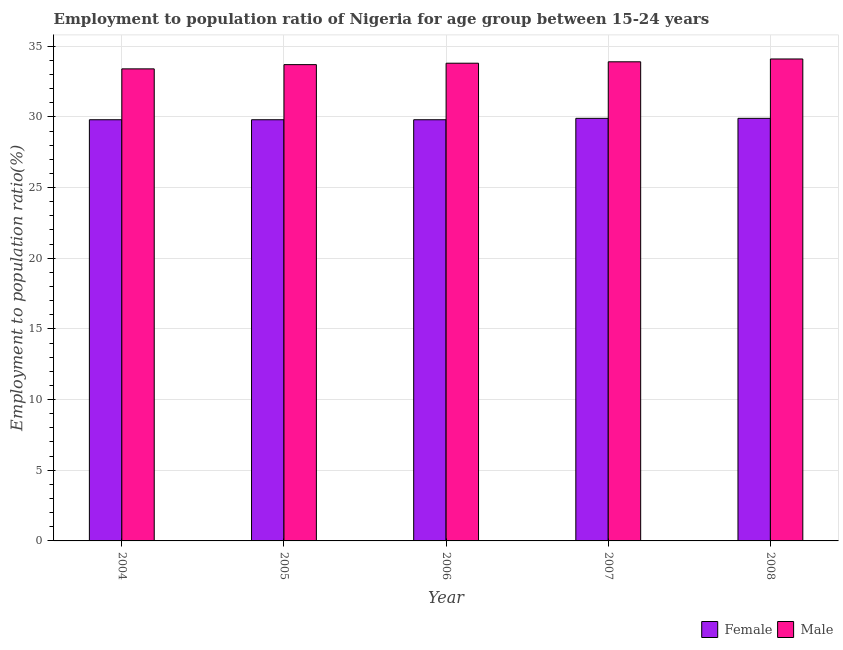How many groups of bars are there?
Make the answer very short. 5. How many bars are there on the 2nd tick from the left?
Give a very brief answer. 2. In how many cases, is the number of bars for a given year not equal to the number of legend labels?
Your answer should be very brief. 0. What is the employment to population ratio(male) in 2008?
Provide a succinct answer. 34.1. Across all years, what is the maximum employment to population ratio(male)?
Your answer should be very brief. 34.1. Across all years, what is the minimum employment to population ratio(female)?
Give a very brief answer. 29.8. In which year was the employment to population ratio(female) maximum?
Give a very brief answer. 2007. In which year was the employment to population ratio(male) minimum?
Your answer should be very brief. 2004. What is the total employment to population ratio(female) in the graph?
Your answer should be compact. 149.2. What is the difference between the employment to population ratio(female) in 2006 and that in 2008?
Provide a short and direct response. -0.1. What is the difference between the employment to population ratio(male) in 2005 and the employment to population ratio(female) in 2007?
Your answer should be compact. -0.2. What is the average employment to population ratio(male) per year?
Keep it short and to the point. 33.78. In how many years, is the employment to population ratio(male) greater than 29 %?
Ensure brevity in your answer.  5. What is the ratio of the employment to population ratio(female) in 2005 to that in 2008?
Your answer should be very brief. 1. Is the difference between the employment to population ratio(male) in 2004 and 2007 greater than the difference between the employment to population ratio(female) in 2004 and 2007?
Your response must be concise. No. What is the difference between the highest and the second highest employment to population ratio(female)?
Your answer should be very brief. 0. What is the difference between the highest and the lowest employment to population ratio(male)?
Ensure brevity in your answer.  0.7. In how many years, is the employment to population ratio(male) greater than the average employment to population ratio(male) taken over all years?
Offer a terse response. 3. What does the 1st bar from the right in 2008 represents?
Provide a short and direct response. Male. Are all the bars in the graph horizontal?
Offer a very short reply. No. How many years are there in the graph?
Your response must be concise. 5. How many legend labels are there?
Your answer should be compact. 2. How are the legend labels stacked?
Offer a very short reply. Horizontal. What is the title of the graph?
Provide a succinct answer. Employment to population ratio of Nigeria for age group between 15-24 years. What is the label or title of the X-axis?
Provide a short and direct response. Year. What is the label or title of the Y-axis?
Provide a succinct answer. Employment to population ratio(%). What is the Employment to population ratio(%) of Female in 2004?
Your answer should be very brief. 29.8. What is the Employment to population ratio(%) of Male in 2004?
Ensure brevity in your answer.  33.4. What is the Employment to population ratio(%) in Female in 2005?
Offer a very short reply. 29.8. What is the Employment to population ratio(%) of Male in 2005?
Your response must be concise. 33.7. What is the Employment to population ratio(%) of Female in 2006?
Your answer should be very brief. 29.8. What is the Employment to population ratio(%) of Male in 2006?
Your response must be concise. 33.8. What is the Employment to population ratio(%) of Female in 2007?
Your answer should be very brief. 29.9. What is the Employment to population ratio(%) in Male in 2007?
Offer a very short reply. 33.9. What is the Employment to population ratio(%) in Female in 2008?
Keep it short and to the point. 29.9. What is the Employment to population ratio(%) of Male in 2008?
Provide a succinct answer. 34.1. Across all years, what is the maximum Employment to population ratio(%) in Female?
Your answer should be compact. 29.9. Across all years, what is the maximum Employment to population ratio(%) in Male?
Keep it short and to the point. 34.1. Across all years, what is the minimum Employment to population ratio(%) of Female?
Your answer should be very brief. 29.8. Across all years, what is the minimum Employment to population ratio(%) in Male?
Your answer should be very brief. 33.4. What is the total Employment to population ratio(%) in Female in the graph?
Provide a succinct answer. 149.2. What is the total Employment to population ratio(%) in Male in the graph?
Keep it short and to the point. 168.9. What is the difference between the Employment to population ratio(%) of Male in 2004 and that in 2005?
Your answer should be compact. -0.3. What is the difference between the Employment to population ratio(%) in Female in 2004 and that in 2006?
Offer a terse response. 0. What is the difference between the Employment to population ratio(%) in Female in 2004 and that in 2007?
Make the answer very short. -0.1. What is the difference between the Employment to population ratio(%) in Male in 2004 and that in 2008?
Make the answer very short. -0.7. What is the difference between the Employment to population ratio(%) in Male in 2005 and that in 2006?
Give a very brief answer. -0.1. What is the difference between the Employment to population ratio(%) in Male in 2005 and that in 2008?
Your answer should be very brief. -0.4. What is the difference between the Employment to population ratio(%) of Female in 2006 and that in 2007?
Provide a short and direct response. -0.1. What is the difference between the Employment to population ratio(%) in Female in 2006 and that in 2008?
Your response must be concise. -0.1. What is the difference between the Employment to population ratio(%) of Female in 2007 and that in 2008?
Your response must be concise. 0. What is the difference between the Employment to population ratio(%) of Male in 2007 and that in 2008?
Your answer should be compact. -0.2. What is the difference between the Employment to population ratio(%) in Female in 2004 and the Employment to population ratio(%) in Male in 2008?
Give a very brief answer. -4.3. What is the difference between the Employment to population ratio(%) in Female in 2005 and the Employment to population ratio(%) in Male in 2008?
Your answer should be compact. -4.3. What is the difference between the Employment to population ratio(%) of Female in 2006 and the Employment to population ratio(%) of Male in 2007?
Provide a succinct answer. -4.1. What is the difference between the Employment to population ratio(%) of Female in 2006 and the Employment to population ratio(%) of Male in 2008?
Your answer should be compact. -4.3. What is the difference between the Employment to population ratio(%) in Female in 2007 and the Employment to population ratio(%) in Male in 2008?
Your answer should be very brief. -4.2. What is the average Employment to population ratio(%) of Female per year?
Your answer should be very brief. 29.84. What is the average Employment to population ratio(%) of Male per year?
Make the answer very short. 33.78. In the year 2005, what is the difference between the Employment to population ratio(%) in Female and Employment to population ratio(%) in Male?
Keep it short and to the point. -3.9. In the year 2008, what is the difference between the Employment to population ratio(%) of Female and Employment to population ratio(%) of Male?
Give a very brief answer. -4.2. What is the ratio of the Employment to population ratio(%) in Female in 2004 to that in 2005?
Your answer should be very brief. 1. What is the ratio of the Employment to population ratio(%) in Male in 2004 to that in 2005?
Offer a terse response. 0.99. What is the ratio of the Employment to population ratio(%) of Female in 2004 to that in 2006?
Make the answer very short. 1. What is the ratio of the Employment to population ratio(%) in Male in 2004 to that in 2007?
Provide a succinct answer. 0.99. What is the ratio of the Employment to population ratio(%) in Male in 2004 to that in 2008?
Provide a succinct answer. 0.98. What is the ratio of the Employment to population ratio(%) in Female in 2005 to that in 2006?
Keep it short and to the point. 1. What is the ratio of the Employment to population ratio(%) in Male in 2005 to that in 2006?
Make the answer very short. 1. What is the ratio of the Employment to population ratio(%) in Female in 2005 to that in 2007?
Your answer should be compact. 1. What is the ratio of the Employment to population ratio(%) in Male in 2005 to that in 2007?
Your response must be concise. 0.99. What is the ratio of the Employment to population ratio(%) of Male in 2005 to that in 2008?
Offer a terse response. 0.99. What is the ratio of the Employment to population ratio(%) of Female in 2006 to that in 2007?
Your response must be concise. 1. What is the ratio of the Employment to population ratio(%) of Female in 2007 to that in 2008?
Make the answer very short. 1. What is the ratio of the Employment to population ratio(%) of Male in 2007 to that in 2008?
Your answer should be very brief. 0.99. What is the difference between the highest and the lowest Employment to population ratio(%) of Female?
Offer a very short reply. 0.1. What is the difference between the highest and the lowest Employment to population ratio(%) of Male?
Offer a terse response. 0.7. 